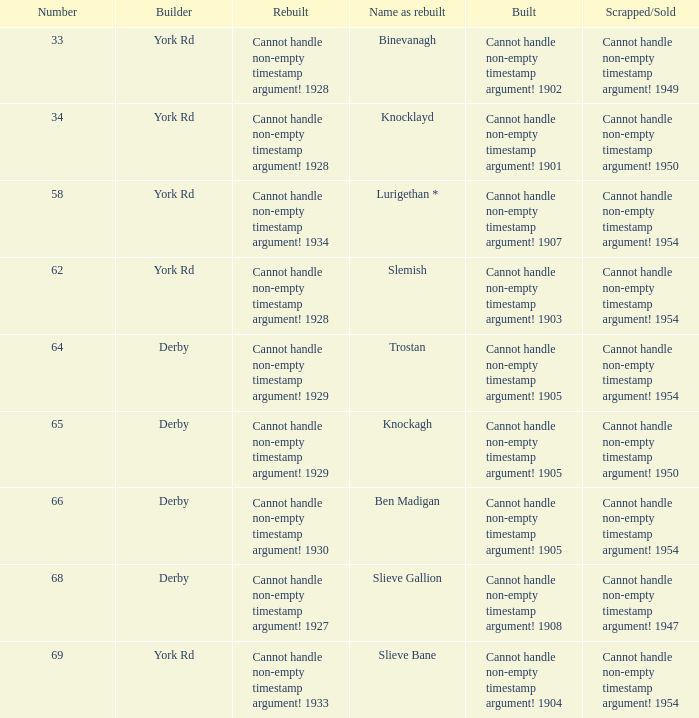Which Scrapped/Sold has a Builder of derby, and a Name as rebuilt of ben madigan? Cannot handle non-empty timestamp argument! 1954. 